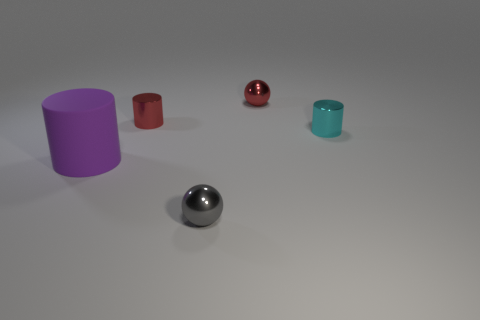Subtract all balls. How many objects are left? 3 Add 4 cyan cylinders. How many objects exist? 9 Add 5 cyan things. How many cyan things are left? 6 Add 2 tiny red metallic spheres. How many tiny red metallic spheres exist? 3 Subtract 1 cyan cylinders. How many objects are left? 4 Subtract all tiny things. Subtract all small red metal cylinders. How many objects are left? 0 